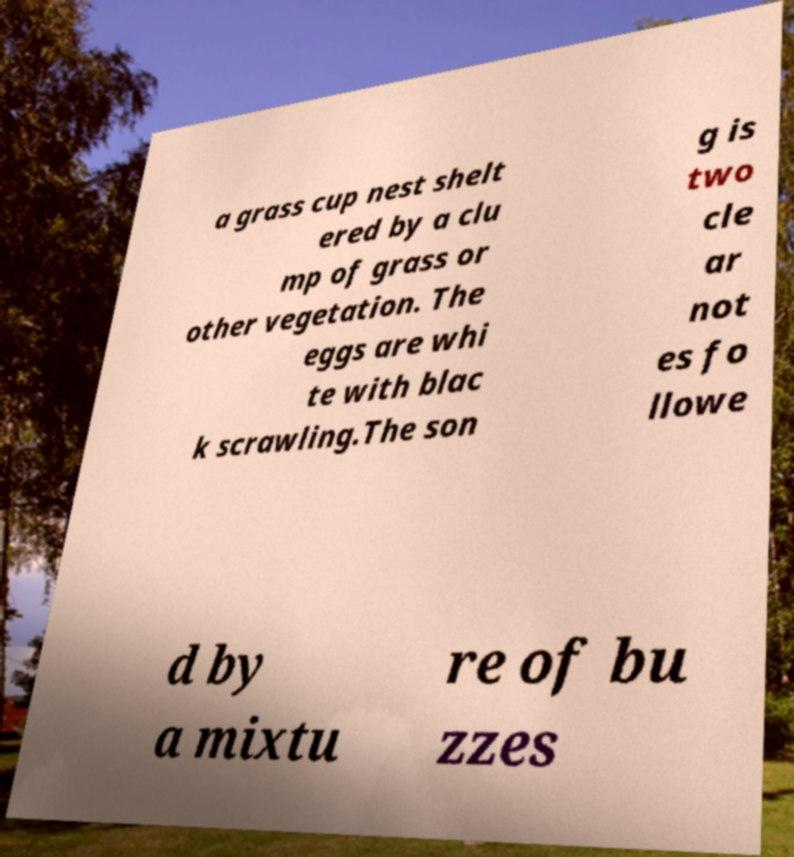Please identify and transcribe the text found in this image. a grass cup nest shelt ered by a clu mp of grass or other vegetation. The eggs are whi te with blac k scrawling.The son g is two cle ar not es fo llowe d by a mixtu re of bu zzes 